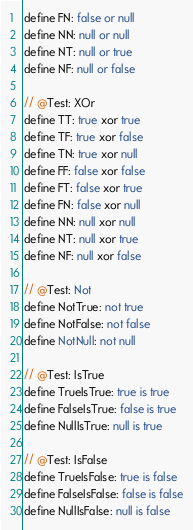<code> <loc_0><loc_0><loc_500><loc_500><_SQL_>define FN: false or null
define NN: null or null
define NT: null or true
define NF: null or false

// @Test: XOr
define TT: true xor true
define TF: true xor false
define TN: true xor null
define FF: false xor false
define FT: false xor true
define FN: false xor null
define NN: null xor null
define NT: null xor true
define NF: null xor false

// @Test: Not
define NotTrue: not true
define NotFalse: not false
define NotNull: not null

// @Test: IsTrue
define TrueIsTrue: true is true
define FalseIsTrue: false is true
define NullIsTrue: null is true

// @Test: IsFalse
define TrueIsFalse: true is false
define FalseIsFalse: false is false
define NullIsFalse: null is false
</code> 